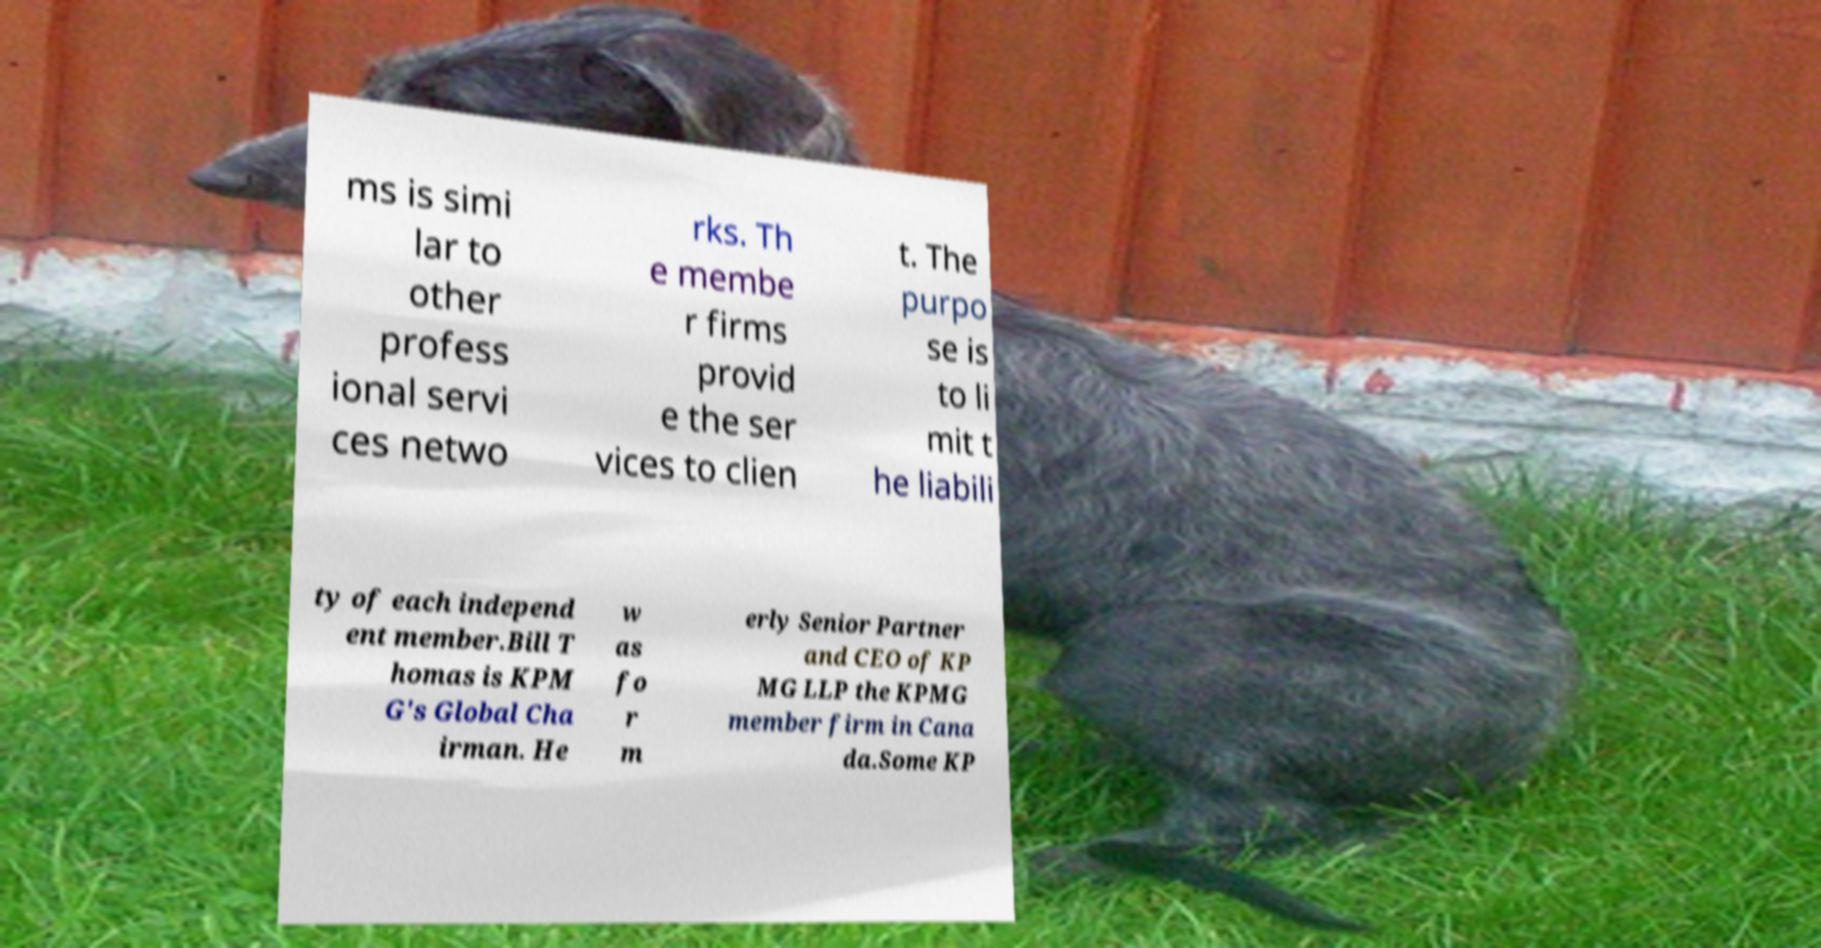There's text embedded in this image that I need extracted. Can you transcribe it verbatim? ms is simi lar to other profess ional servi ces netwo rks. Th e membe r firms provid e the ser vices to clien t. The purpo se is to li mit t he liabili ty of each independ ent member.Bill T homas is KPM G's Global Cha irman. He w as fo r m erly Senior Partner and CEO of KP MG LLP the KPMG member firm in Cana da.Some KP 